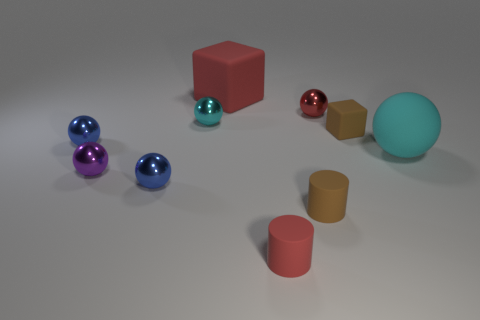There is a sphere that is to the right of the small shiny object that is behind the cyan metal sphere; how big is it?
Make the answer very short. Large. There is a red cube that is the same size as the matte ball; what is it made of?
Your answer should be very brief. Rubber. Is there a cyan object that has the same material as the tiny red cylinder?
Offer a very short reply. Yes. What color is the matte cube that is in front of the big matte thing to the left of the tiny brown rubber block that is to the right of the purple metal object?
Offer a terse response. Brown. Do the tiny thing that is on the left side of the purple metallic thing and the shiny ball in front of the purple sphere have the same color?
Give a very brief answer. Yes. Is there anything else of the same color as the big cube?
Give a very brief answer. Yes. Are there fewer big things that are left of the tiny brown rubber cylinder than rubber things?
Keep it short and to the point. Yes. How many tiny green metallic spheres are there?
Make the answer very short. 0. Does the large cyan thing have the same shape as the brown matte object on the right side of the tiny red shiny thing?
Provide a short and direct response. No. Are there fewer tiny brown blocks to the right of the big cyan matte sphere than tiny brown matte things that are right of the tiny purple metallic object?
Give a very brief answer. Yes. 